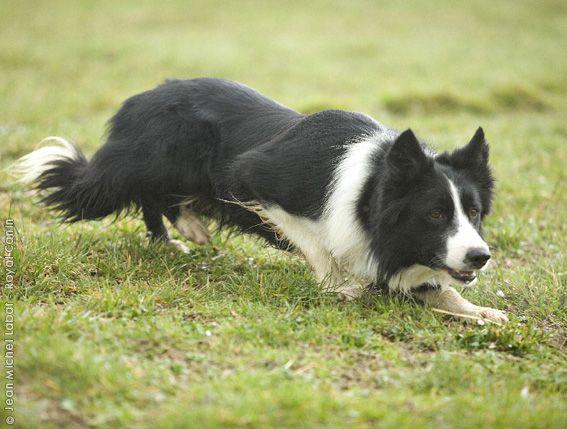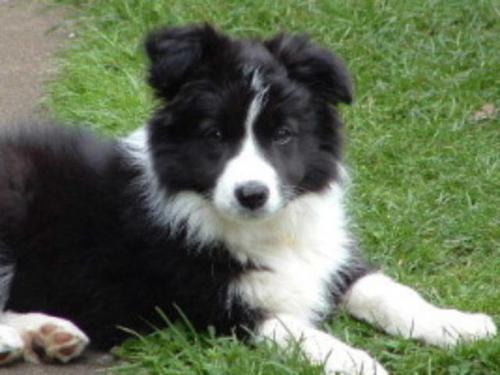The first image is the image on the left, the second image is the image on the right. Considering the images on both sides, is "There is one border calling laying down in the grass." valid? Answer yes or no. Yes. The first image is the image on the left, the second image is the image on the right. Considering the images on both sides, is "One of the dogs is lying on grass with its head up." valid? Answer yes or no. Yes. 